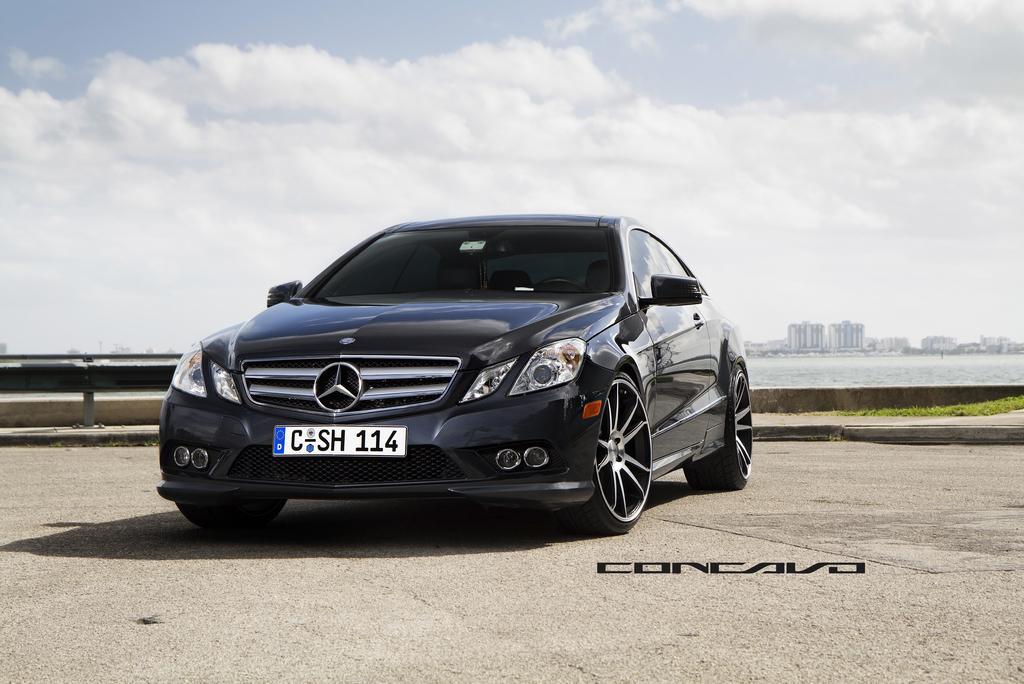Can you describe this image briefly? In this image there is a car on the road. Behind the car there's grass on the ground. Behind it there is the water. In the background there are buildings. At the top there is the sky. To the left there is a railing. At the bottom there is text on the image. 